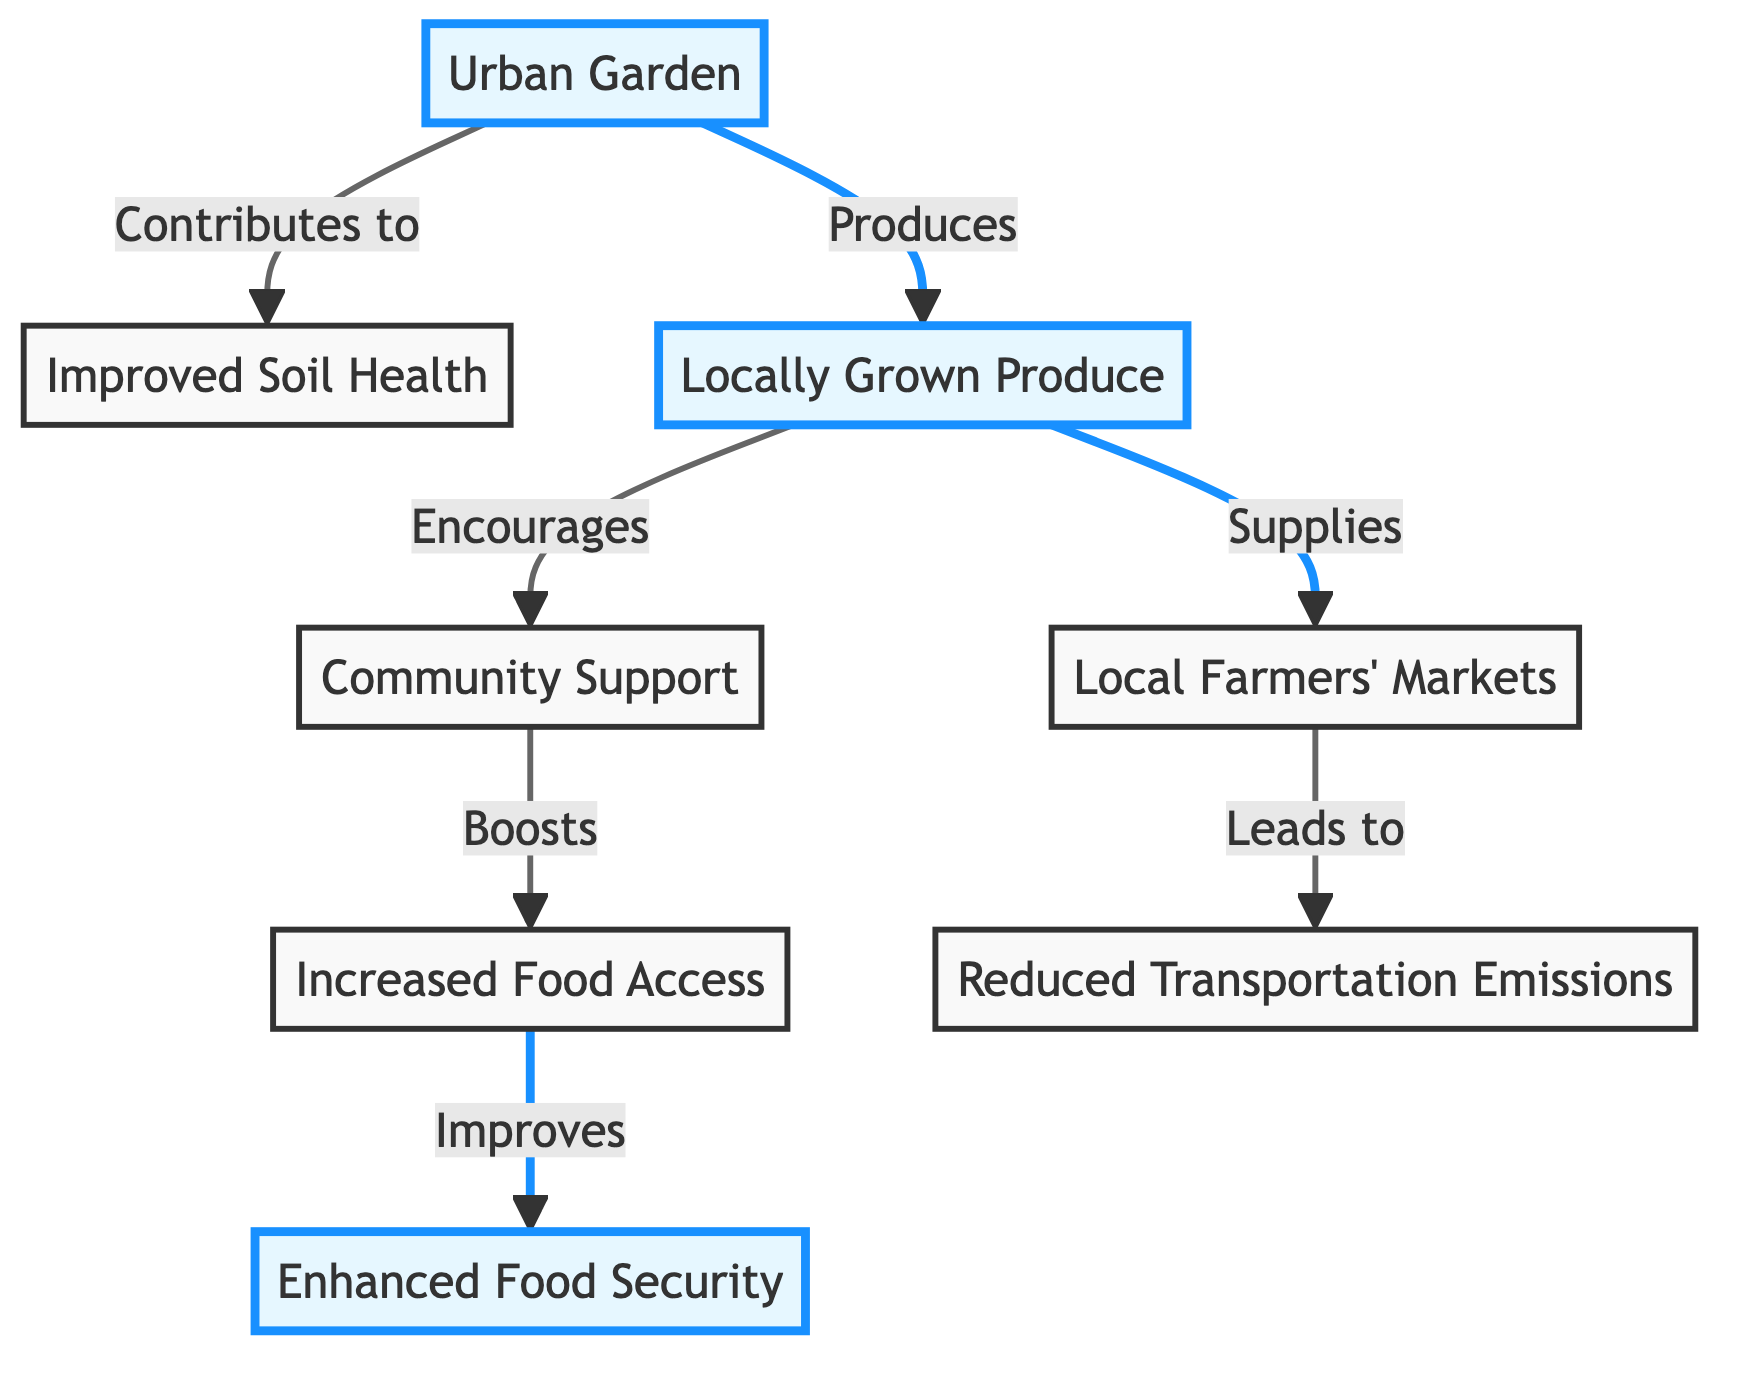What is the main source in this food chain? The main source in the food chain is the "Urban Garden," which initiates the flow of elements in the diagram.
Answer: Urban Garden How many nodes are in the diagram? To find the number of nodes, we count each labeled box present in the diagram: "Urban Garden," "Improved Soil Health," "Locally Grown Produce," "Community Support," "Increased Food Access," "Local Farmers' Markets," "Reduced Transportation Emissions," and "Enhanced Food Security," resulting in a total of 8 nodes.
Answer: 8 What does the "Local Farmers' Markets" lead to? The "Local Farmers' Markets" node leads to "Reduced Transportation Emissions," showing the impact of local produce on transportation needs.
Answer: Reduced Transportation Emissions Which two nodes connect through "Encourages"? The nodes that connect through "Encourages" are "Locally Grown Produce" and "Community Support," indicating the relationship formed through the production of local food.
Answer: Locally Grown Produce and Community Support How does "Community Support" affect food access? "Community Support" boosts "Increased Food Access," indicating that a supportive community enhances access to food resources.
Answer: Boosts What is the end effect of improved food access in the diagram? The end effect of improved food access in the diagram is "Enhanced Food Security," showing the final outcome of increased access to food.
Answer: Enhanced Food Security Which step reduces environmental impact in the food chain? The step that reduces environmental impact is the "Reduced Transportation Emissions," which comes from sourcing food locally through urban gardens.
Answer: Reduced Transportation Emissions How does local produce affect the community? Local produce encourages community support, illustrating how local food initiatives foster stronger community ties.
Answer: Encourages What do improved soil health and locally grown produce contribute to? Improved soil health and locally grown produce contribute to "Increased Food Access," highlighting their role in making food resources more available.
Answer: Increased Food Access 